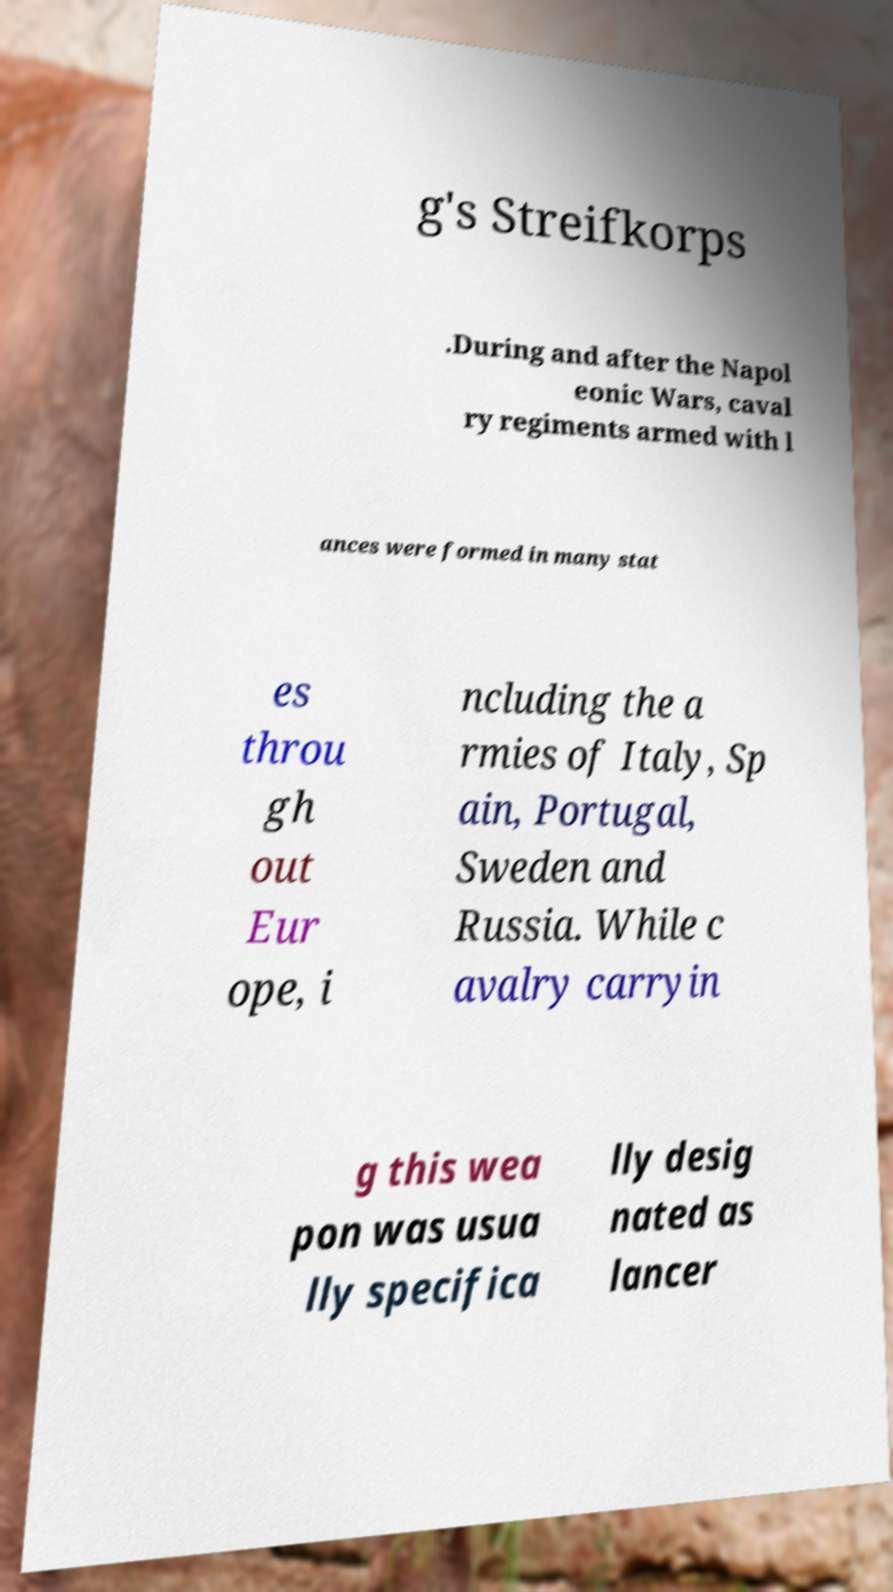For documentation purposes, I need the text within this image transcribed. Could you provide that? g's Streifkorps .During and after the Napol eonic Wars, caval ry regiments armed with l ances were formed in many stat es throu gh out Eur ope, i ncluding the a rmies of Italy, Sp ain, Portugal, Sweden and Russia. While c avalry carryin g this wea pon was usua lly specifica lly desig nated as lancer 